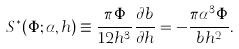Convert formula to latex. <formula><loc_0><loc_0><loc_500><loc_500>S ^ { * } ( \Phi ; \alpha , h ) \equiv \frac { \pi \Phi } { 1 2 h ^ { 3 } } \frac { \partial b } { \partial h } = - \frac { \pi \alpha ^ { 3 } \Phi } { b h ^ { 2 } } .</formula> 